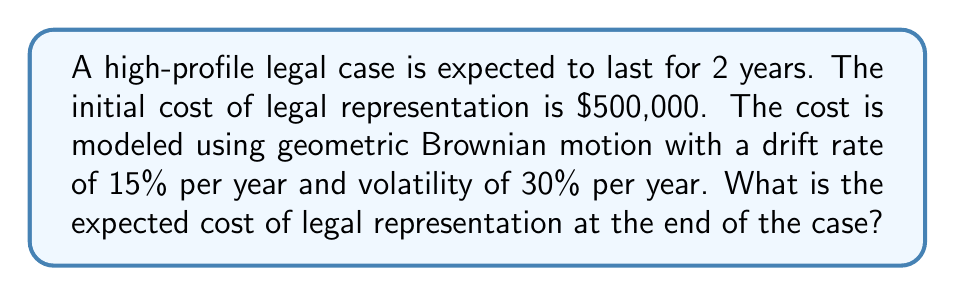Can you answer this question? To solve this problem, we'll use the properties of geometric Brownian motion:

1) The expected value of a geometric Brownian motion is given by:

   $$E[S_t] = S_0 e^{\mu t}$$

   where $S_0$ is the initial value, $\mu$ is the drift rate, and $t$ is the time.

2) In this case:
   $S_0 = 500,000$
   $\mu = 15\% = 0.15$
   $t = 2$ years

3) Note that the volatility ($\sigma = 30\%$) doesn't affect the expected value, only the variance.

4) Plugging these values into the formula:

   $$E[S_2] = 500,000 \cdot e^{0.15 \cdot 2}$$

5) Simplify:
   $$E[S_2] = 500,000 \cdot e^{0.3}$$

6) Calculate:
   $$E[S_2] = 500,000 \cdot 1.34986$$
   $$E[S_2] = 674,930$$

Therefore, the expected cost of legal representation at the end of the 2-year case is $674,930.
Answer: $674,930 